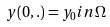<formula> <loc_0><loc_0><loc_500><loc_500>y ( 0 , . ) = y _ { 0 } i n \Omega</formula> 